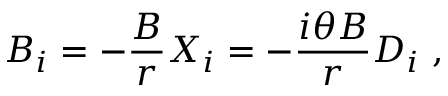Convert formula to latex. <formula><loc_0><loc_0><loc_500><loc_500>B _ { i } = - \frac { B } { r } X _ { i } = - \frac { i \theta B } { r } D _ { i } ,</formula> 